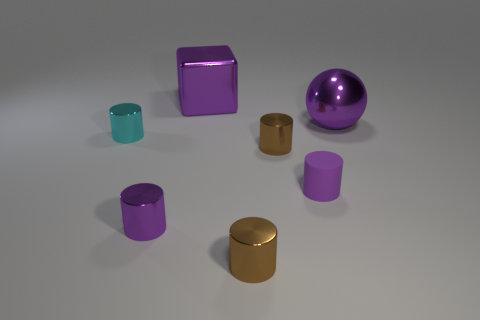Subtract all cyan cylinders. How many cylinders are left? 4 Subtract all cyan spheres. How many purple cylinders are left? 2 Add 2 big purple objects. How many objects exist? 9 Subtract all cyan cylinders. How many cylinders are left? 4 Subtract 1 cylinders. How many cylinders are left? 4 Subtract 0 yellow balls. How many objects are left? 7 Subtract all cylinders. How many objects are left? 2 Subtract all green spheres. Subtract all purple cubes. How many spheres are left? 1 Subtract all tiny blue matte objects. Subtract all small purple shiny cylinders. How many objects are left? 6 Add 4 small purple things. How many small purple things are left? 6 